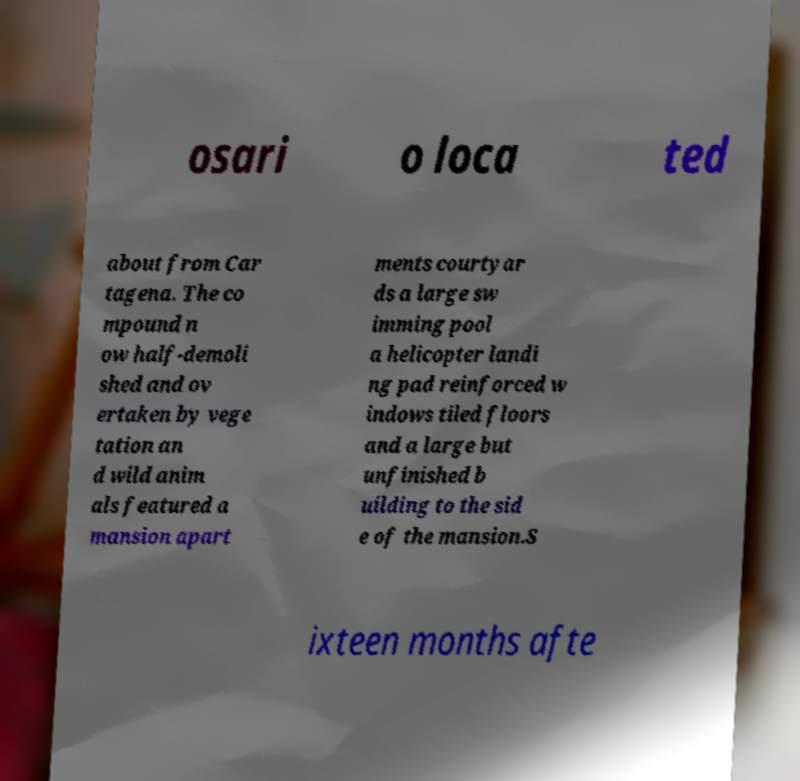Could you assist in decoding the text presented in this image and type it out clearly? osari o loca ted about from Car tagena. The co mpound n ow half-demoli shed and ov ertaken by vege tation an d wild anim als featured a mansion apart ments courtyar ds a large sw imming pool a helicopter landi ng pad reinforced w indows tiled floors and a large but unfinished b uilding to the sid e of the mansion.S ixteen months afte 